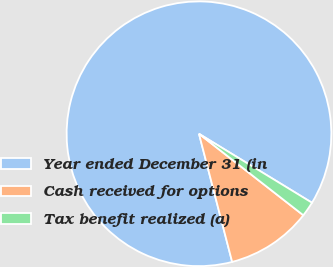Convert chart to OTSL. <chart><loc_0><loc_0><loc_500><loc_500><pie_chart><fcel>Year ended December 31 (in<fcel>Cash received for options<fcel>Tax benefit realized (a)<nl><fcel>87.75%<fcel>10.42%<fcel>1.83%<nl></chart> 